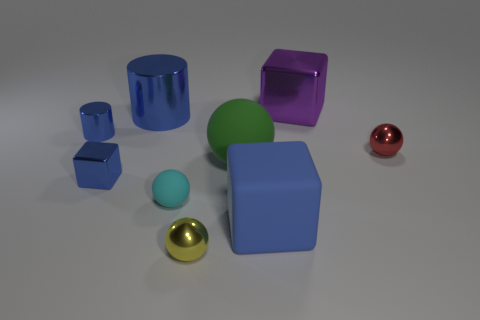How many blue cylinders must be subtracted to get 1 blue cylinders? 1 Subtract all green balls. Subtract all purple cylinders. How many balls are left? 3 Add 1 small metallic things. How many objects exist? 10 Subtract all cubes. How many objects are left? 6 Add 7 green matte blocks. How many green matte blocks exist? 7 Subtract 0 brown cylinders. How many objects are left? 9 Subtract all small red balls. Subtract all blue cubes. How many objects are left? 6 Add 5 big purple cubes. How many big purple cubes are left? 6 